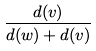<formula> <loc_0><loc_0><loc_500><loc_500>\frac { d ( v ) } { d ( w ) + d ( v ) }</formula> 